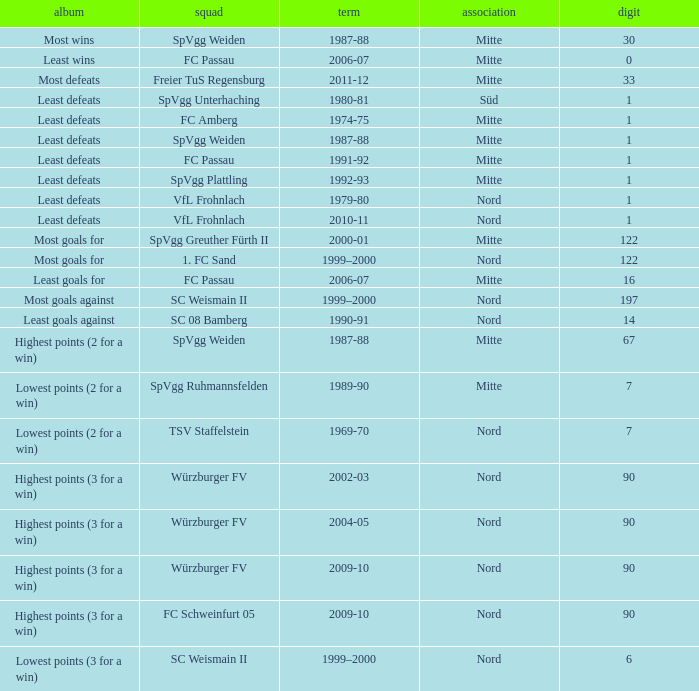What team has 2000-01 as the season? SpVgg Greuther Fürth II. Could you parse the entire table as a dict? {'header': ['album', 'squad', 'term', 'association', 'digit'], 'rows': [['Most wins', 'SpVgg Weiden', '1987-88', 'Mitte', '30'], ['Least wins', 'FC Passau', '2006-07', 'Mitte', '0'], ['Most defeats', 'Freier TuS Regensburg', '2011-12', 'Mitte', '33'], ['Least defeats', 'SpVgg Unterhaching', '1980-81', 'Süd', '1'], ['Least defeats', 'FC Amberg', '1974-75', 'Mitte', '1'], ['Least defeats', 'SpVgg Weiden', '1987-88', 'Mitte', '1'], ['Least defeats', 'FC Passau', '1991-92', 'Mitte', '1'], ['Least defeats', 'SpVgg Plattling', '1992-93', 'Mitte', '1'], ['Least defeats', 'VfL Frohnlach', '1979-80', 'Nord', '1'], ['Least defeats', 'VfL Frohnlach', '2010-11', 'Nord', '1'], ['Most goals for', 'SpVgg Greuther Fürth II', '2000-01', 'Mitte', '122'], ['Most goals for', '1. FC Sand', '1999–2000', 'Nord', '122'], ['Least goals for', 'FC Passau', '2006-07', 'Mitte', '16'], ['Most goals against', 'SC Weismain II', '1999–2000', 'Nord', '197'], ['Least goals against', 'SC 08 Bamberg', '1990-91', 'Nord', '14'], ['Highest points (2 for a win)', 'SpVgg Weiden', '1987-88', 'Mitte', '67'], ['Lowest points (2 for a win)', 'SpVgg Ruhmannsfelden', '1989-90', 'Mitte', '7'], ['Lowest points (2 for a win)', 'TSV Staffelstein', '1969-70', 'Nord', '7'], ['Highest points (3 for a win)', 'Würzburger FV', '2002-03', 'Nord', '90'], ['Highest points (3 for a win)', 'Würzburger FV', '2004-05', 'Nord', '90'], ['Highest points (3 for a win)', 'Würzburger FV', '2009-10', 'Nord', '90'], ['Highest points (3 for a win)', 'FC Schweinfurt 05', '2009-10', 'Nord', '90'], ['Lowest points (3 for a win)', 'SC Weismain II', '1999–2000', 'Nord', '6']]} 